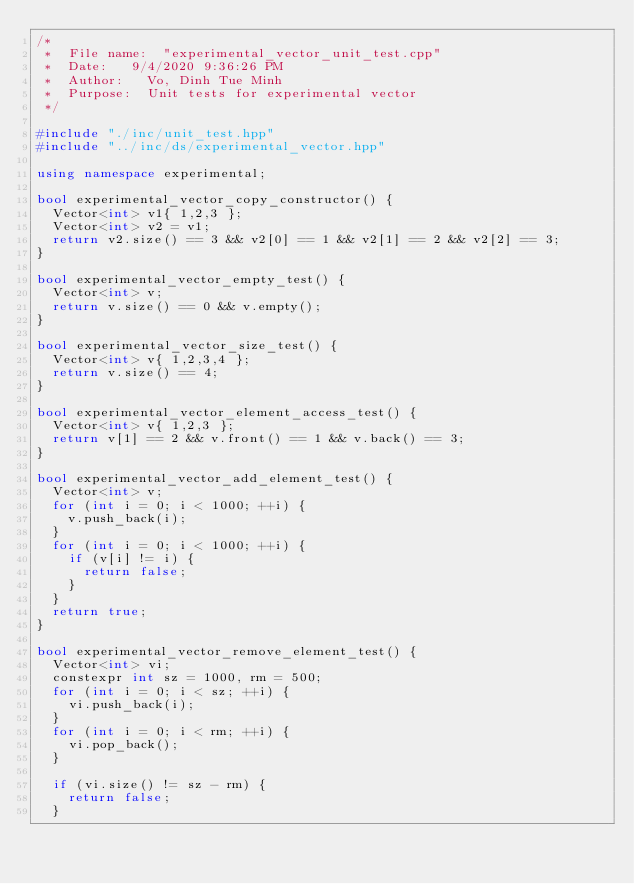Convert code to text. <code><loc_0><loc_0><loc_500><loc_500><_C++_>/*
 *	File name:	"experimental_vector_unit_test.cpp"
 *	Date:		9/4/2020 9:36:26 PM
 *	Author:		Vo, Dinh Tue Minh
 *	Purpose:	Unit tests for experimental vector
 */

#include "./inc/unit_test.hpp"
#include "../inc/ds/experimental_vector.hpp"

using namespace experimental;

bool experimental_vector_copy_constructor() {
	Vector<int> v1{ 1,2,3 };
	Vector<int> v2 = v1;
	return v2.size() == 3 && v2[0] == 1 && v2[1] == 2 && v2[2] == 3;
}

bool experimental_vector_empty_test() {
	Vector<int> v;
	return v.size() == 0 && v.empty();
}

bool experimental_vector_size_test() {
	Vector<int> v{ 1,2,3,4 };
	return v.size() == 4;
}

bool experimental_vector_element_access_test() {
	Vector<int> v{ 1,2,3 };
	return v[1] == 2 && v.front() == 1 && v.back() == 3;
}

bool experimental_vector_add_element_test() {
	Vector<int> v;
	for (int i = 0; i < 1000; ++i) {
		v.push_back(i);
	}
	for (int i = 0; i < 1000; ++i) {
		if (v[i] != i) {
			return false;
		}
	}
	return true;
}

bool experimental_vector_remove_element_test() {
	Vector<int> vi;
	constexpr int sz = 1000, rm = 500;
	for (int i = 0; i < sz; ++i) {
		vi.push_back(i);
	}
	for (int i = 0; i < rm; ++i) {
		vi.pop_back();
	}

	if (vi.size() != sz - rm) {
		return false;
	}</code> 